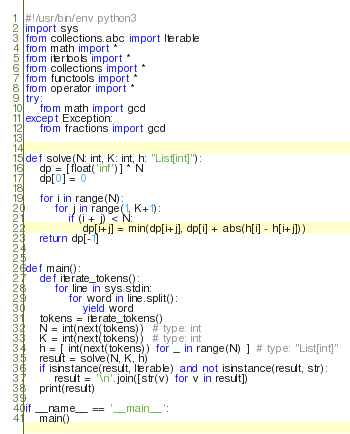Convert code to text. <code><loc_0><loc_0><loc_500><loc_500><_Python_>#!/usr/bin/env python3
import sys
from collections.abc import Iterable
from math import *
from itertools import *
from collections import *
from functools import *
from operator import *
try:
    from math import gcd
except Exception:
    from fractions import gcd


def solve(N: int, K: int, h: "List[int]"):
    dp = [float('inf')] * N
    dp[0] = 0

    for i in range(N):
        for j in range(1, K+1):
            if (i + j) < N:
                dp[i+j] = min(dp[i+j], dp[i] + abs(h[i] - h[i+j]))
    return dp[-1]


def main():
    def iterate_tokens():
        for line in sys.stdin:
            for word in line.split():
                yield word
    tokens = iterate_tokens()
    N = int(next(tokens))  # type: int
    K = int(next(tokens))  # type: int
    h = [ int(next(tokens)) for _ in range(N) ]  # type: "List[int]"
    result = solve(N, K, h)
    if isinstance(result, Iterable) and not isinstance(result, str):
        result = '\n'.join([str(v) for v in result])
    print(result)

if __name__ == '__main__':
    main()
</code> 